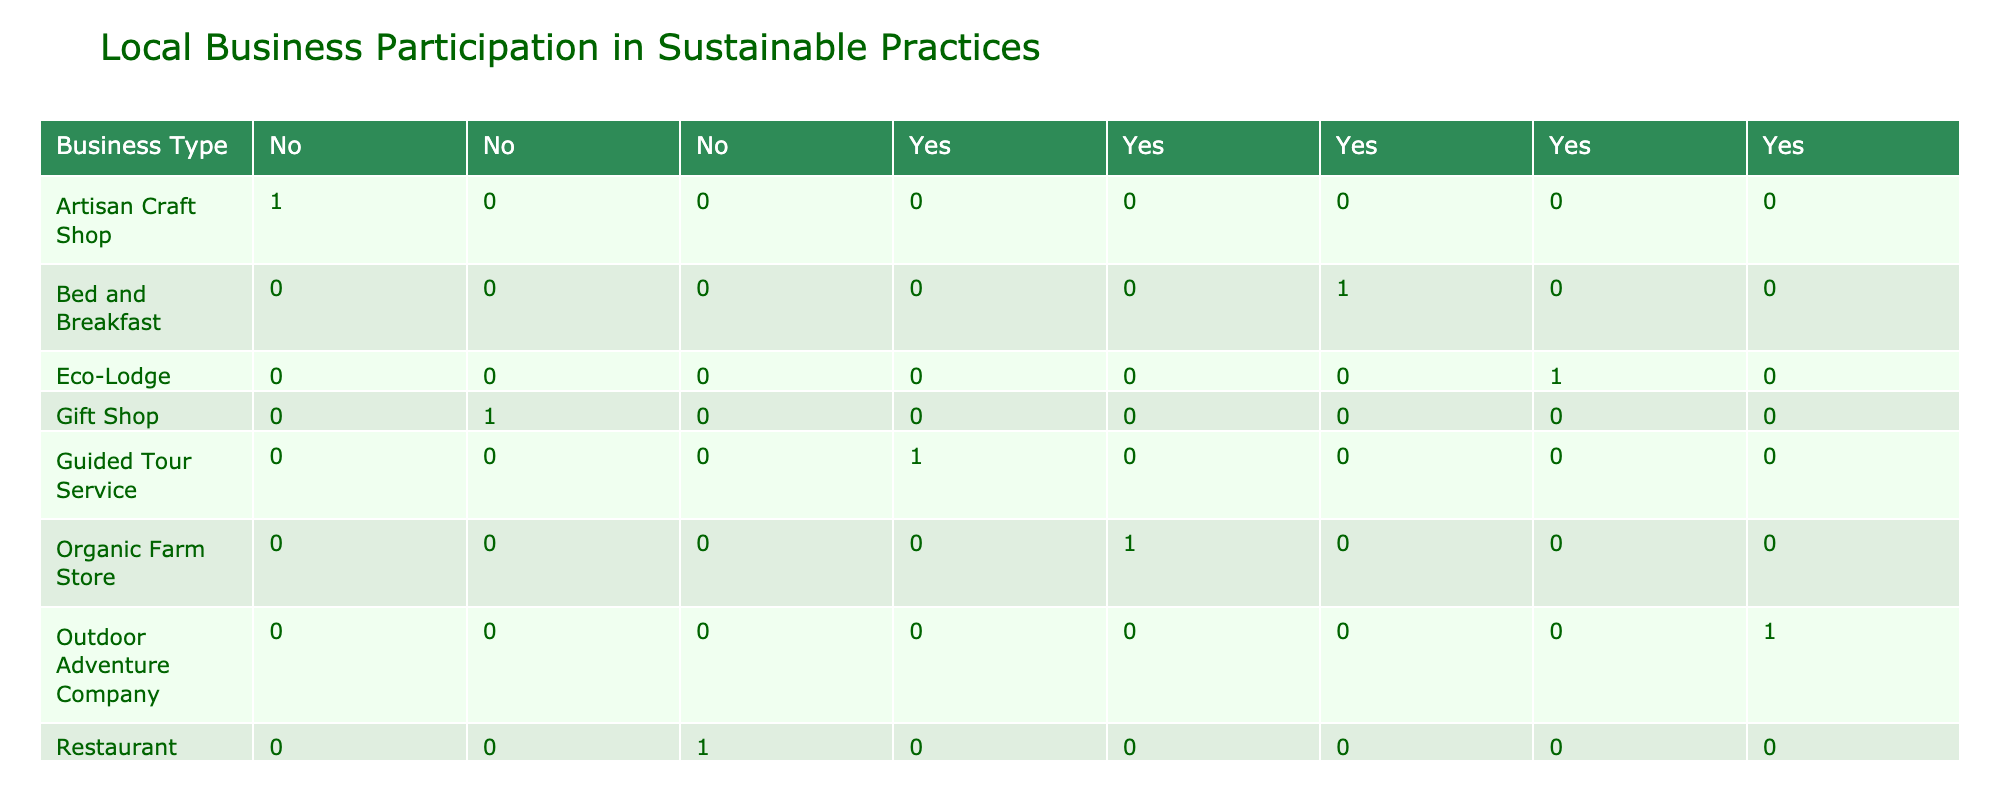What is the only business type that does not have a recycling program? According to the table, the Artisan Craft Shop, Restaurant, and Gift Shop all have "No" marked under the Recycling Program. Among these, the only one noted as not engaging in this practice at all is the Gift Shop.
Answer: Gift Shop How many businesses engage in local sourcing? By examining the table, we find that the Outdoor Adventure Company, Artisan Craft Shop, Organic Farm Store, Eco-Lodge, Restaurant, Gift Shop, and Guided Tour Service. This adds up to a total of six businesses actively sourcing materials locally.
Answer: 6 Which business type has the highest engagement in community activities? Focusing on the Community Engagement column, both the Outdoor Adventure Company and Eco-Lodge have significant activities listed. However, the Outdoor Adventure Company also engages in Guided Nature Walks, indicating a greater level of community-driven activity. Hence, it can be concluded to have higher engagement compared to others.
Answer: Outdoor Adventure Company Is it true that the Eco-Lodge also practices wildlife protection? The table shows "Yes" under Wildlife Protection for the Eco-Lodge. This confirms that this type of business indeed prioritizes the protection of wildlife in its sustainable practices.
Answer: Yes What percentage of businesses are using energy-efficient lights or equipment? There are 8 businesses in total, out of which 4 (Outdoor Adventure Company, Organic Farm Store, Eco-Lodge, and Guided Tour Service) use energy-efficient solutions. To find the percentage, divide the number of businesses using energy-efficient practices (4) by the total number of businesses (8), then multiply by 100. This results in 4/8 * 100 = 50%.
Answer: 50% How does the participation in recycling programs compare between Outdoor Adventure Company and Organic Farm Store? Both the Outdoor Adventure Company and Organic Farm Store participate in recycling programs, but the Organic Farm Store also includes more sustainable sourcing from local farmers, suggesting a deeper commitment to sustainability beyond recycling alone. Thus, while they are equal in one aspect, Organic Farm Store shows additional engagement in local sourcing.
Answer: Equal, but Organic Farm Store is more engaged in other practices Which business types are involved in both community engagement and wildlife protection? The only business types listed that engage in both community activities and wildlife protection are the Eco-Lodge and Outdoor Adventure Company, indicating they are taking steps towards engaging the local community while also considering wildlife preservation.
Answer: Eco-Lodge, Outdoor Adventure Company How many more businesses are engaged in community engagement than those that use energy-efficient equipment? From the table, 5 businesses engage in community activities (Outdoor Adventure Company, Organic Farm Store, Eco-Lodge, Guided Tour Service, and the Restaurant). On the other hand, 4 businesses use energy-efficient solutions (Outdoor Adventure Company, Organic Farm Store, Eco-Lodge, and Guided Tour Service). Thus, the difference is 5 - 4 = 1.
Answer: 1 Which business has the least sustainable practices based on the table? By examining all columns, the Gift Shop shows "No" in key aspects like the Recycling Program, Local Sourcing, Energy Efficiency, Community Engagement, and Wildlife Protection. This signifies that it lacks multiple sustainable practices, setting it apart as the least engaged in sustainability efforts.
Answer: Gift Shop 